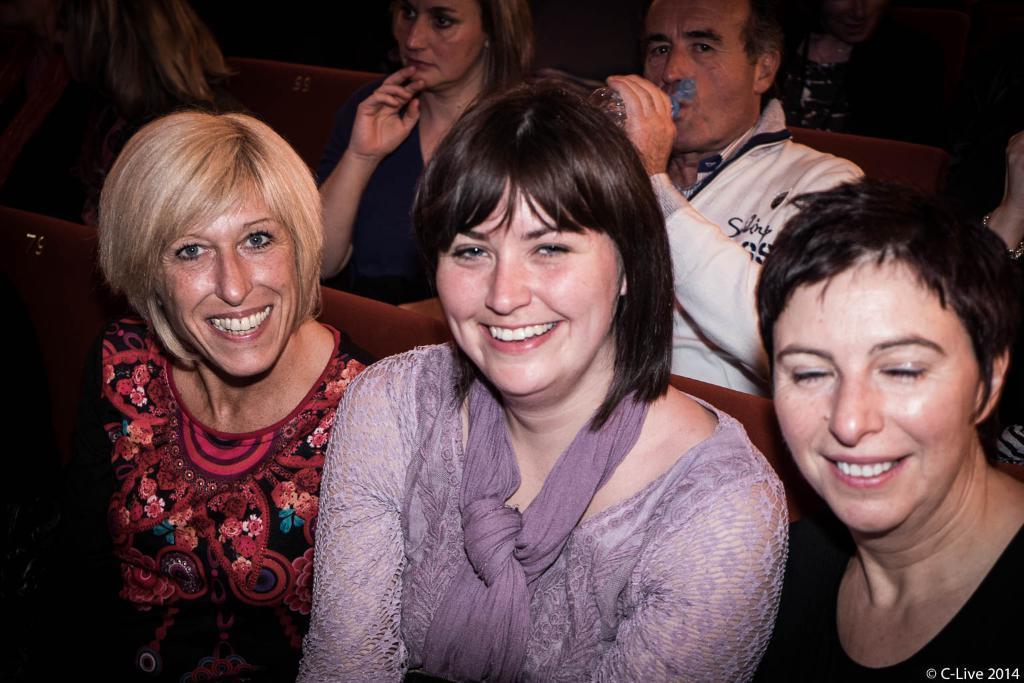Could you give a brief overview of what you see in this image? In the picture I can see people are sitting on chairs among them these three women are smiling and the man in the the background is holding a bottle in the hand. On the bottom right side of the image I can see a watermark. 